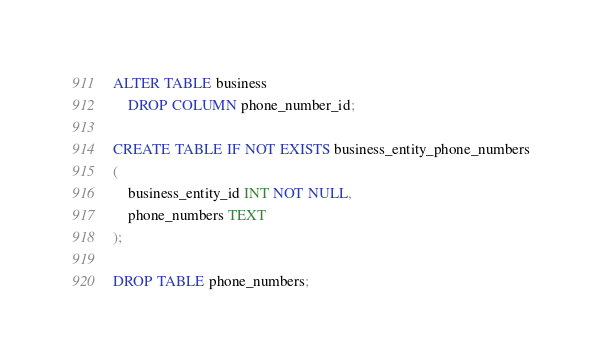Convert code to text. <code><loc_0><loc_0><loc_500><loc_500><_SQL_>ALTER TABLE business
    DROP COLUMN phone_number_id;

CREATE TABLE IF NOT EXISTS business_entity_phone_numbers
(
    business_entity_id INT NOT NULL,
    phone_numbers TEXT
);

DROP TABLE phone_numbers;</code> 